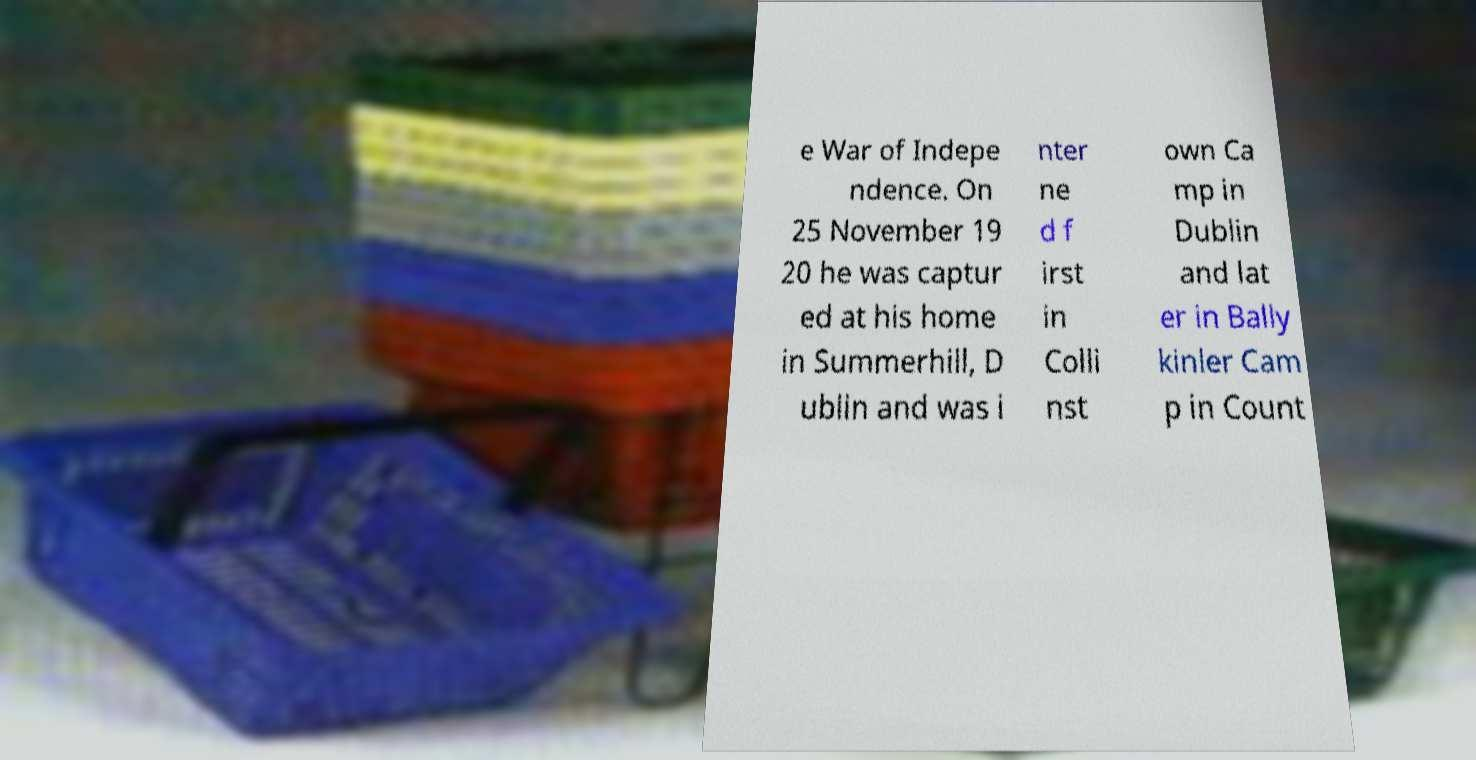There's text embedded in this image that I need extracted. Can you transcribe it verbatim? e War of Indepe ndence. On 25 November 19 20 he was captur ed at his home in Summerhill, D ublin and was i nter ne d f irst in Colli nst own Ca mp in Dublin and lat er in Bally kinler Cam p in Count 